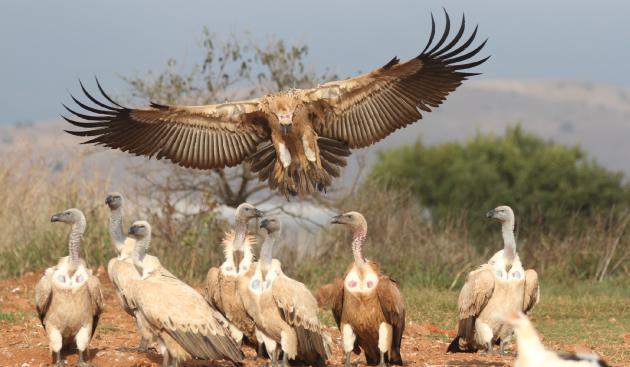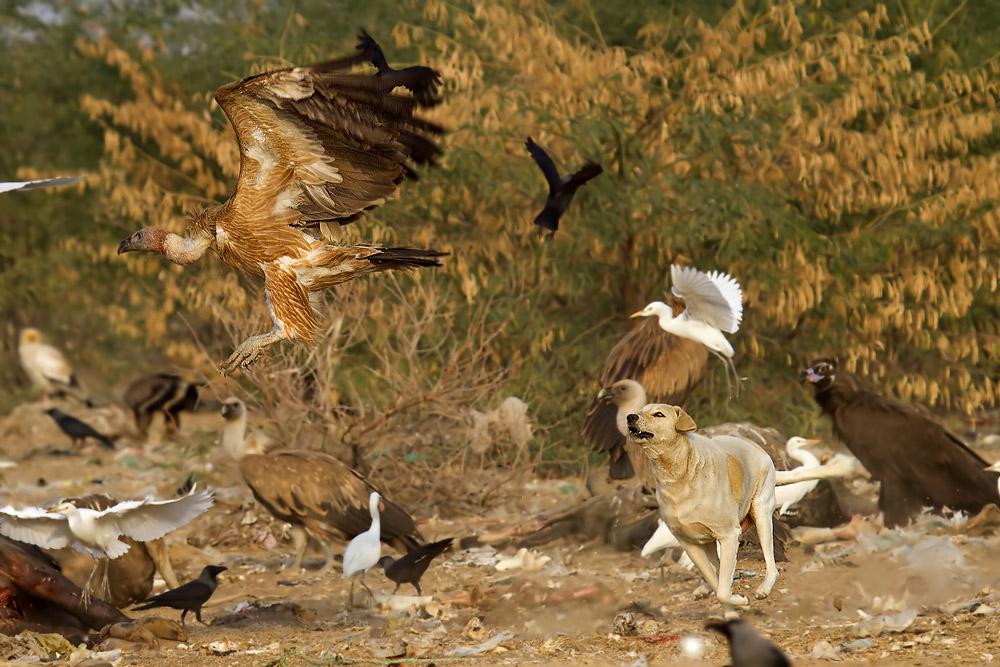The first image is the image on the left, the second image is the image on the right. For the images shown, is this caption "There is exactly one bird in one of the images." true? Answer yes or no. No. 